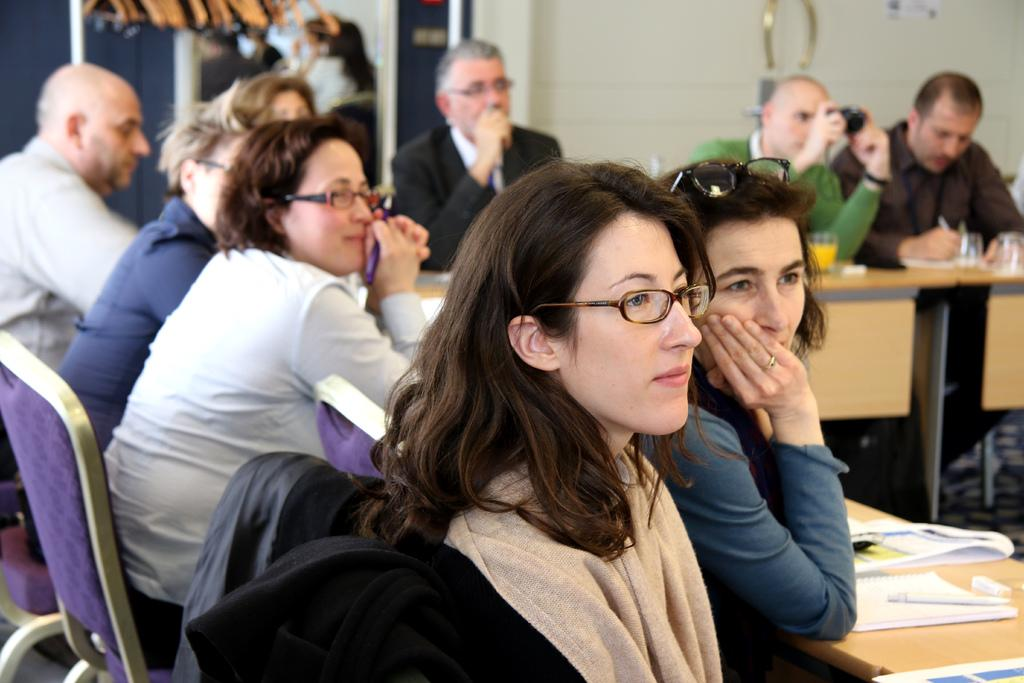How many people are in the image? There is a group of people in the image, but the exact number is not specified. What are the people doing in the image? The people are sitting at a table in the image. What might the people be looking at? The people are looking at something, but the specific object or subject is not mentioned in the facts. What type of stem can be seen growing from the shelf in the image? There is no shelf or stem present in the image. 